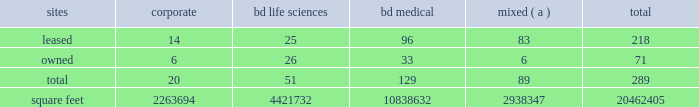Item 2 .
Properties .
Bd 2019s executive offices are located in franklin lakes , new jersey .
As of october 31 , 2017 , bd owned or leased 289 facilities throughout the world , comprising approximately 20462405 square feet of manufacturing , warehousing , administrative and research facilities .
The u.s .
Facilities , including those in puerto rico , comprise approximately 7472419 square feet of owned and 2976267 square feet of leased space .
The international facilities comprise approximately 7478714 square feet of owned and 2535005 square feet of leased space .
Sales offices and distribution centers included in the total square footage are also located throughout the world .
Operations in each of bd 2019s business segments are conducted at both u.s .
And international locations .
Particularly in the international marketplace , facilities often serve more than one business segment and are used for multiple purposes , such as administrative/sales , manufacturing and/or warehousing/distribution .
Bd generally seeks to own its manufacturing facilities , although some are leased .
The table summarizes property information by business segment. .
( a ) facilities used by more than one business segment .
Bd believes that its facilities are of good construction and in good physical condition , are suitable and adequate for the operations conducted at those facilities , and are , with minor exceptions , fully utilized and operating at normal capacity .
The u.s .
Facilities are located in alabama , arizona , california , connecticut , florida , georgia , illinois , indiana , maryland , massachusetts , michigan , missouri , nebraska , new jersey , north carolina , ohio , oklahoma , south carolina , texas , utah , virginia , washington , d.c. , washington , wisconsin and puerto rico .
The international facilities are as follows : - europe , middle east , africa , which includes facilities in austria , belgium , bosnia and herzegovina , the czech republic , denmark , england , finland , france , germany , ghana , hungary , ireland , israel , italy , kenya , luxembourg , netherlands , norway , poland , portugal , russia , saudi arabia , south africa , spain , sweden , switzerland , turkey , the united arab emirates and zambia .
- greater asia , which includes facilities in australia , bangladesh , china , india , indonesia , japan , malaysia , new zealand , the philippines , singapore , south korea , taiwan , thailand and vietnam .
- latin america , which includes facilities in argentina , brazil , chile , colombia , mexico , peru and the dominican republic .
- canada .
Item 3 .
Legal proceedings .
Information with respect to certain legal proceedings is included in note 5 to the consolidated financial statements contained in item 8 .
Financial statements and supplementary data , and is incorporated herein by reference .
Item 4 .
Mine safety disclosures .
Not applicable. .
What is the proportion of leased corporate units to owned corporate units? 
Computations: (14 / 6)
Answer: 2.33333. 